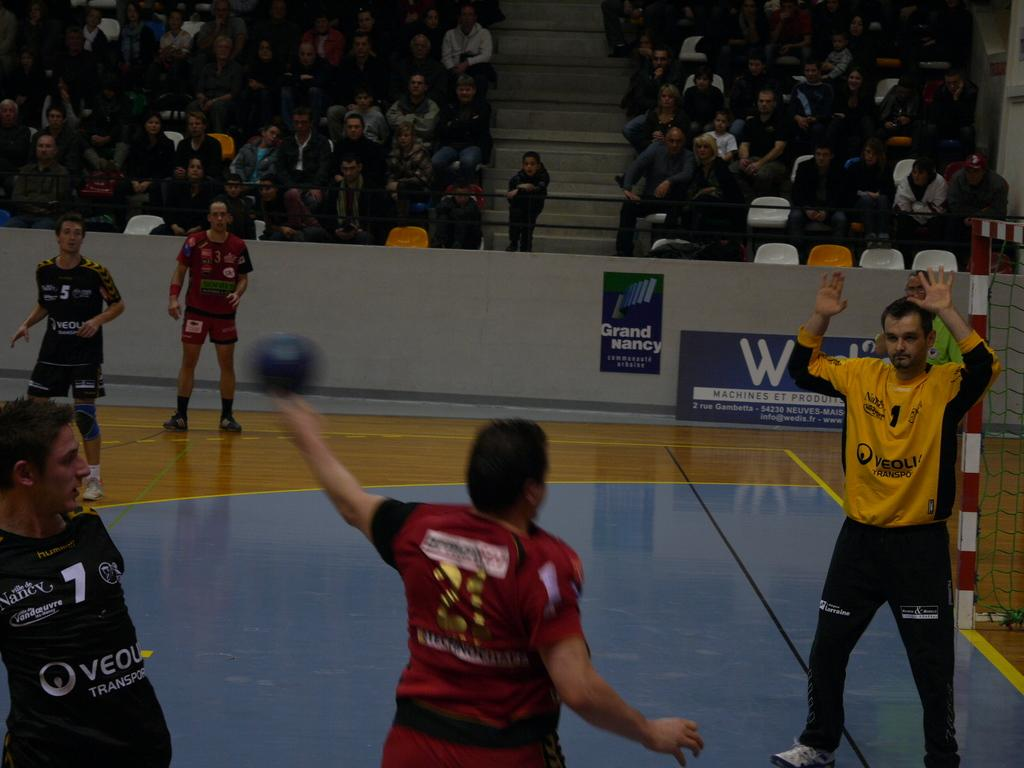<image>
Create a compact narrative representing the image presented. A ball player wearing a black shirt with Nancy and Vandoruvre on it. 